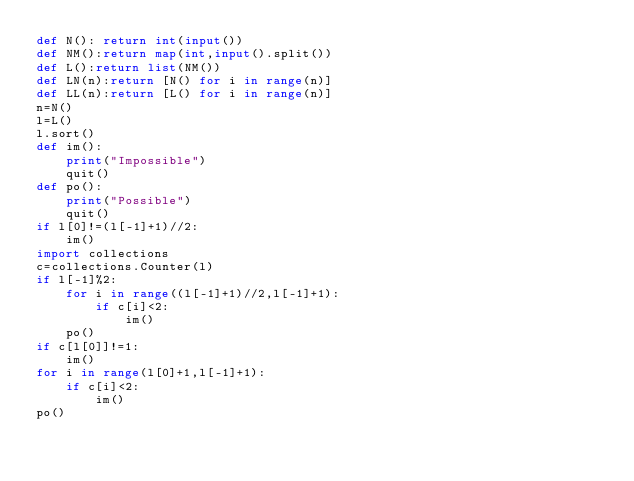<code> <loc_0><loc_0><loc_500><loc_500><_Python_>def N(): return int(input())
def NM():return map(int,input().split())
def L():return list(NM())
def LN(n):return [N() for i in range(n)]
def LL(n):return [L() for i in range(n)]
n=N()
l=L()
l.sort()
def im():
    print("Impossible")
    quit()
def po():
    print("Possible")
    quit()
if l[0]!=(l[-1]+1)//2:
    im()
import collections
c=collections.Counter(l)
if l[-1]%2:
    for i in range((l[-1]+1)//2,l[-1]+1):
        if c[i]<2:
            im()
    po()
if c[l[0]]!=1:
    im()
for i in range(l[0]+1,l[-1]+1):
    if c[i]<2:
        im()
po()</code> 